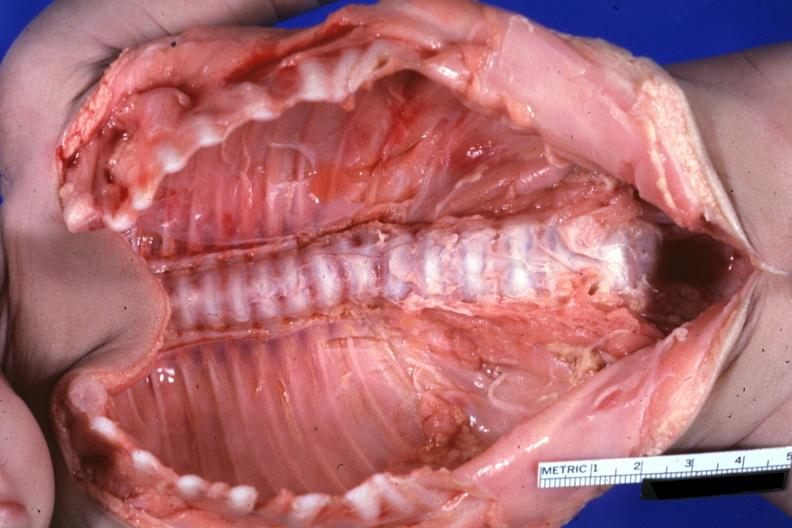does choanal patency show opened body cavity natural color lesion at t12 see protocol?
Answer the question using a single word or phrase. No 